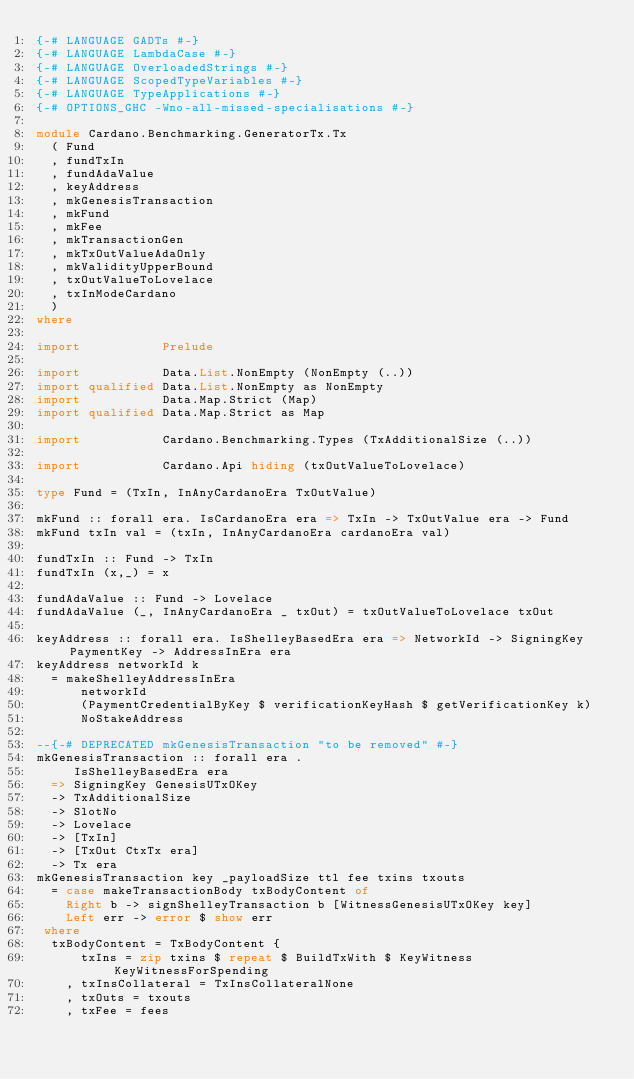Convert code to text. <code><loc_0><loc_0><loc_500><loc_500><_Haskell_>{-# LANGUAGE GADTs #-}
{-# LANGUAGE LambdaCase #-}
{-# LANGUAGE OverloadedStrings #-}
{-# LANGUAGE ScopedTypeVariables #-}
{-# LANGUAGE TypeApplications #-}
{-# OPTIONS_GHC -Wno-all-missed-specialisations #-}

module Cardano.Benchmarking.GeneratorTx.Tx
  ( Fund
  , fundTxIn
  , fundAdaValue
  , keyAddress
  , mkGenesisTransaction
  , mkFund
  , mkFee
  , mkTransactionGen
  , mkTxOutValueAdaOnly
  , mkValidityUpperBound
  , txOutValueToLovelace
  , txInModeCardano
  )
where

import           Prelude

import           Data.List.NonEmpty (NonEmpty (..))
import qualified Data.List.NonEmpty as NonEmpty
import           Data.Map.Strict (Map)
import qualified Data.Map.Strict as Map

import           Cardano.Benchmarking.Types (TxAdditionalSize (..))

import           Cardano.Api hiding (txOutValueToLovelace)

type Fund = (TxIn, InAnyCardanoEra TxOutValue)

mkFund :: forall era. IsCardanoEra era => TxIn -> TxOutValue era -> Fund
mkFund txIn val = (txIn, InAnyCardanoEra cardanoEra val)

fundTxIn :: Fund -> TxIn
fundTxIn (x,_) = x

fundAdaValue :: Fund -> Lovelace
fundAdaValue (_, InAnyCardanoEra _ txOut) = txOutValueToLovelace txOut

keyAddress :: forall era. IsShelleyBasedEra era => NetworkId -> SigningKey PaymentKey -> AddressInEra era
keyAddress networkId k
  = makeShelleyAddressInEra
      networkId
      (PaymentCredentialByKey $ verificationKeyHash $ getVerificationKey k)
      NoStakeAddress

--{-# DEPRECATED mkGenesisTransaction "to be removed" #-}
mkGenesisTransaction :: forall era .
     IsShelleyBasedEra era
  => SigningKey GenesisUTxOKey
  -> TxAdditionalSize
  -> SlotNo
  -> Lovelace
  -> [TxIn]
  -> [TxOut CtxTx era]
  -> Tx era
mkGenesisTransaction key _payloadSize ttl fee txins txouts
  = case makeTransactionBody txBodyContent of
    Right b -> signShelleyTransaction b [WitnessGenesisUTxOKey key]
    Left err -> error $ show err
 where
  txBodyContent = TxBodyContent {
      txIns = zip txins $ repeat $ BuildTxWith $ KeyWitness KeyWitnessForSpending
    , txInsCollateral = TxInsCollateralNone
    , txOuts = txouts
    , txFee = fees</code> 